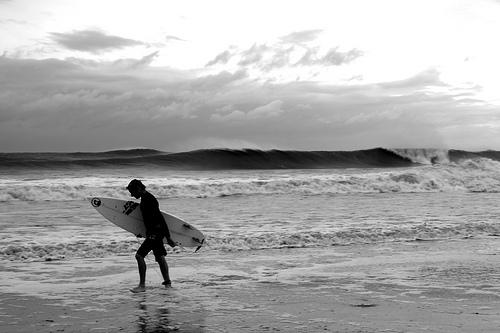Describe the elements that make this image a classic waterfront scene. The image features a surfer holding his white surfboard on a wet sandy beach, facing high waves crashing ashore, and a grey, cloudy sky above. Choose a caption that most accurately describes the image. Man holding a white surfboard on a wet sandy beach with high waves coming to shore. Identify the activity the man is doing and the object he is holding. The man is holding a surfboard and is getting ready to surf. In a poetic way, describe the atmosphere of the image. A lone surfer stands poised, gripping his white board amidst the rolling, white-crested waves on a wet, sandy beach as grey clouds meander in the sky above. What can be inferred about the man's state after his surf session? The man seems to be finishing surfing for the day, his feet are wet as he walks on the beach. Imagine this photo being used for a movie poster. What could be the tagline for the movie? "Against the unforgiving waves, one man dares to conquer the force of nature." For a surfing gears advertisement, describe the board and the wetsuit in the photo. Introducing our sleek and lightweight white surfboard, perfect for conquering the roughest seas. Pair it with our black wetsuit - flexible, comfortable, and designed to keep you warm in the coldest waters. Determine the state of the sand, waves, and sky in the picture. The sand is wet, the waves are high and white, and the sky is grey and cloudy. How can you characterize the overall look and feel of the photo? It is a dramatic and atmospheric black and white photo of a surfer on a wet beach with high waves and a cloudy sky. What is the color scheme of the photo, and what is the man wearing? The photo is in black and white, and the man is wearing a black wetsuit. 